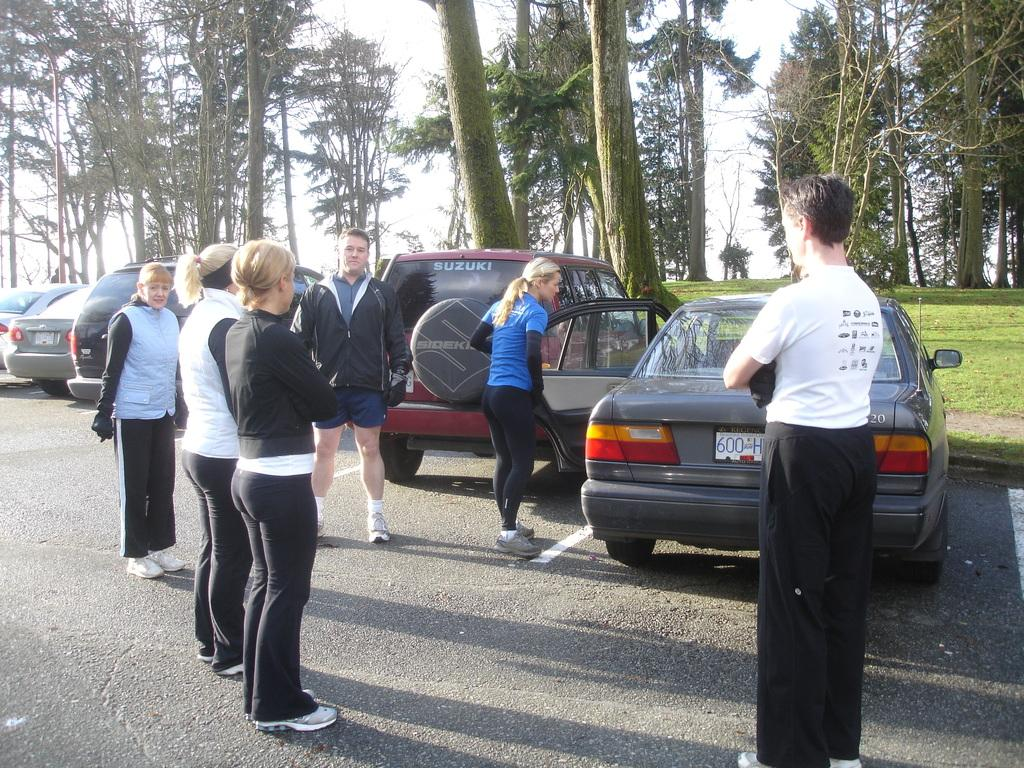What are the people in the image doing? The people in the image are standing on the road. What else can be seen on the road besides the people? Cars are visible in the image. What type of vegetation is present in the image? Grass and trees are visible in the image. What object can be seen in the image that is not a part of the natural environment? There is a pole in the image. What is visible in the background of the image? The sky is visible in the background of the image. Can you see a robin perched on the pole in the image? There is no robin present in the image; only people, cars, grass, trees, a pole, and the sky are visible. 